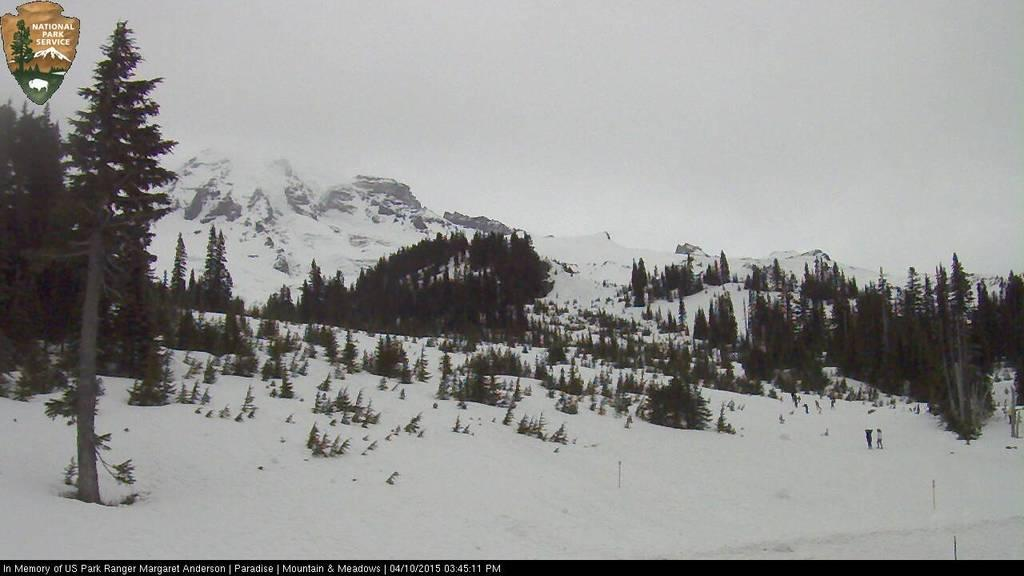What type of natural features can be seen in the image? There are trees and mountains in the image. What is the weather like in the image? There is snow visible in the image, which suggests a cold or wintery climate. What part of the natural environment is visible in the image? The sky is visible in the background of the image. What type of wine is being served at the mountain summit in the image? There is no wine or indication of a gathering in the image; it simply features trees, mountains, snow, and the sky. 